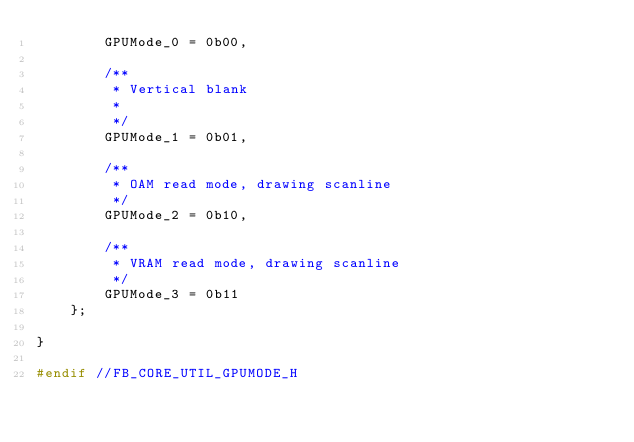<code> <loc_0><loc_0><loc_500><loc_500><_C_>        GPUMode_0 = 0b00,

        /**
         * Vertical blank
         *
         */
        GPUMode_1 = 0b01,

        /**
         * OAM read mode, drawing scanline
         */
        GPUMode_2 = 0b10,

        /**
         * VRAM read mode, drawing scanline
         */
        GPUMode_3 = 0b11
    };

}

#endif //FB_CORE_UTIL_GPUMODE_H
</code> 